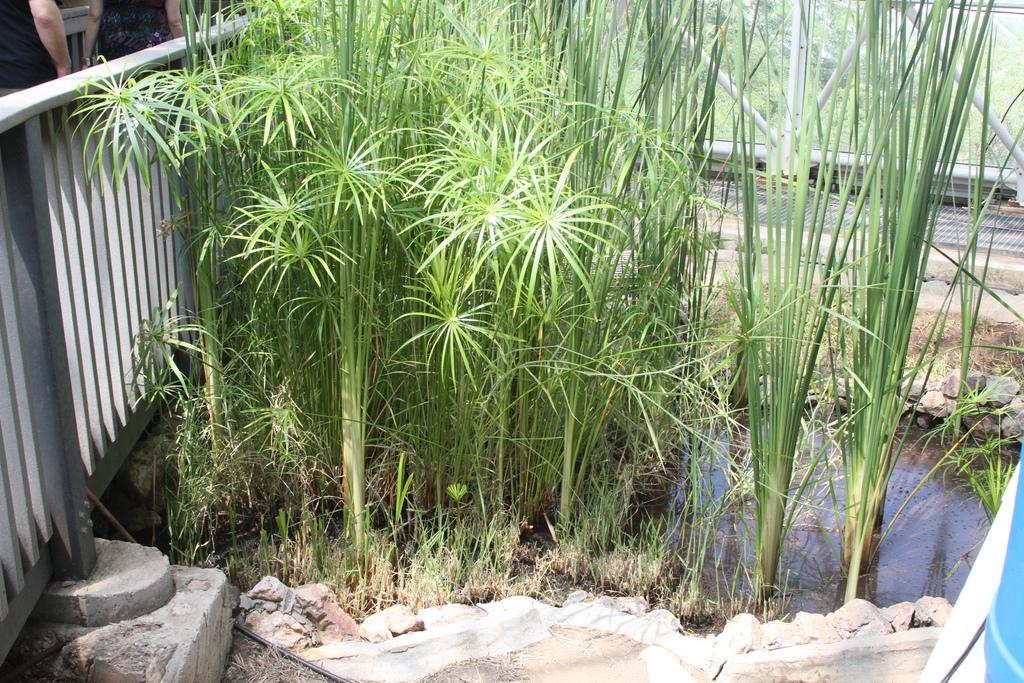How many people are present in the image? There are two persons in the image. What type of structure can be seen in the image? There are iron grills in the image. What type of vegetation is present in the image? There are plants and grass in the image. What is the water element in the image? There is water visible in the image. What can be seen in the background of the image? There are trees in the background of the image. What type of rail can be seen in the image? There is no rail present in the image. How many beads are visible on the plants in the image? There are no beads present on the plants in the image. 